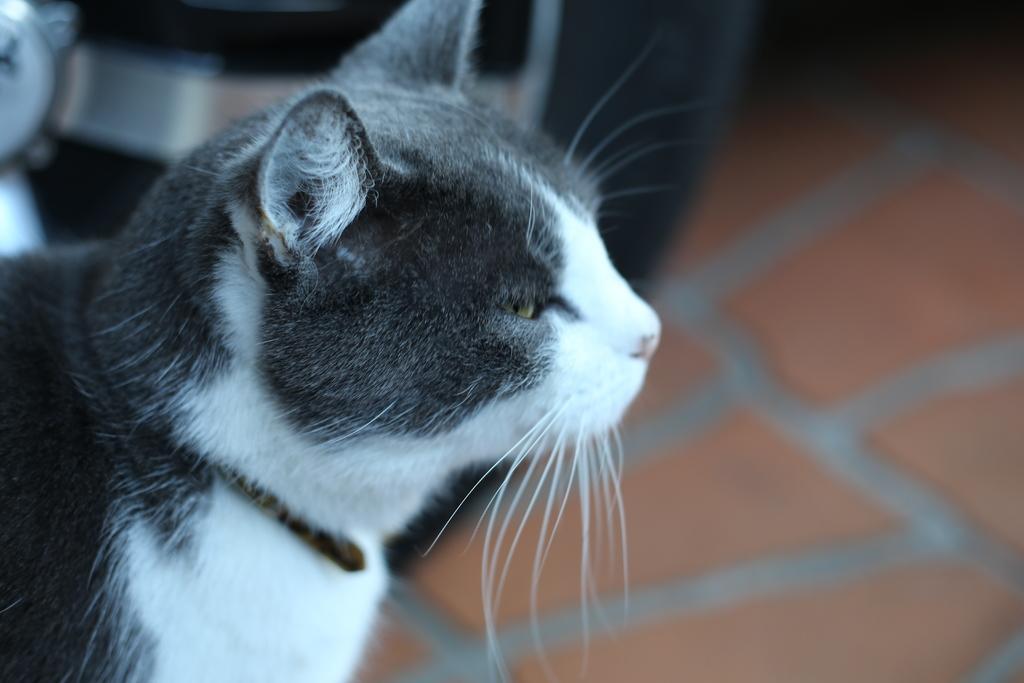How would you summarize this image in a sentence or two? This picture shows a cat. It is white and black in color. 